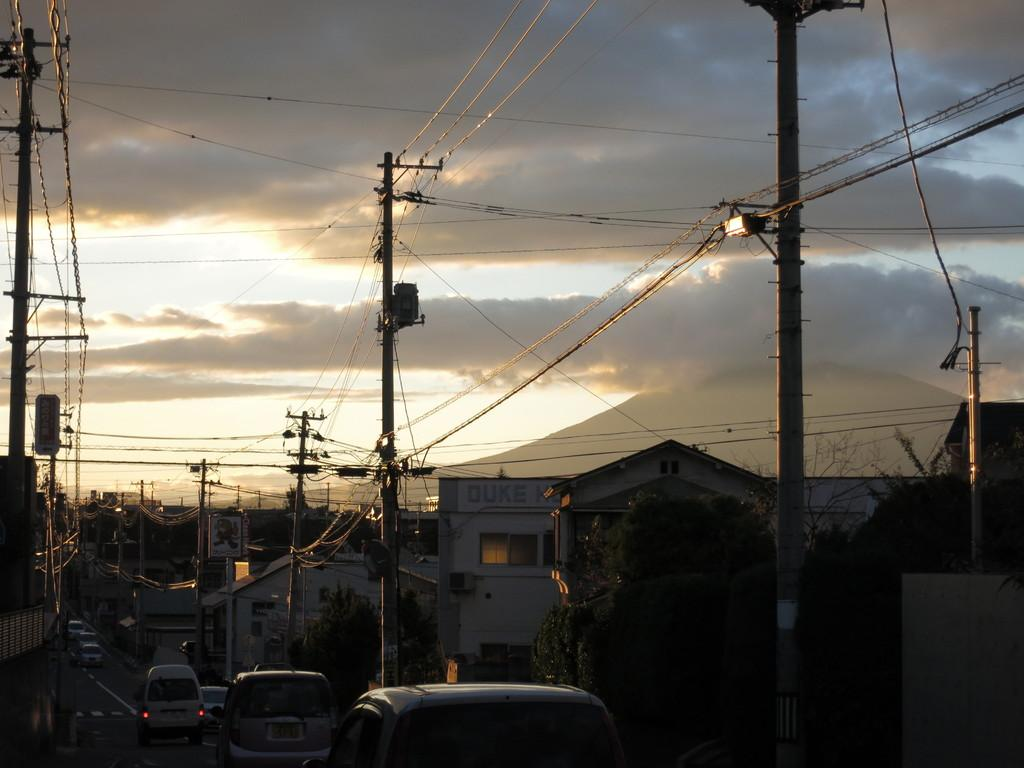What type of vehicles are at the bottom side of the image? There are cars at the bottom side of the image. What structures are present in the image? There are houses in the image. What type of vegetation can be seen in the image? There are trees in the image. What is attached to the pole in the image? There is a pole with wires in the image. Where are the wires located in the image? The wires are at the top side of the image. Can you hear the whistle of the wind blowing through the trees in the image? There is no mention of wind or a whistle in the image, so we cannot determine if it can be heard. Did the earthquake cause any damage to the houses in the image? There is no mention of an earthquake in the image, so we cannot determine if it caused any damage. 